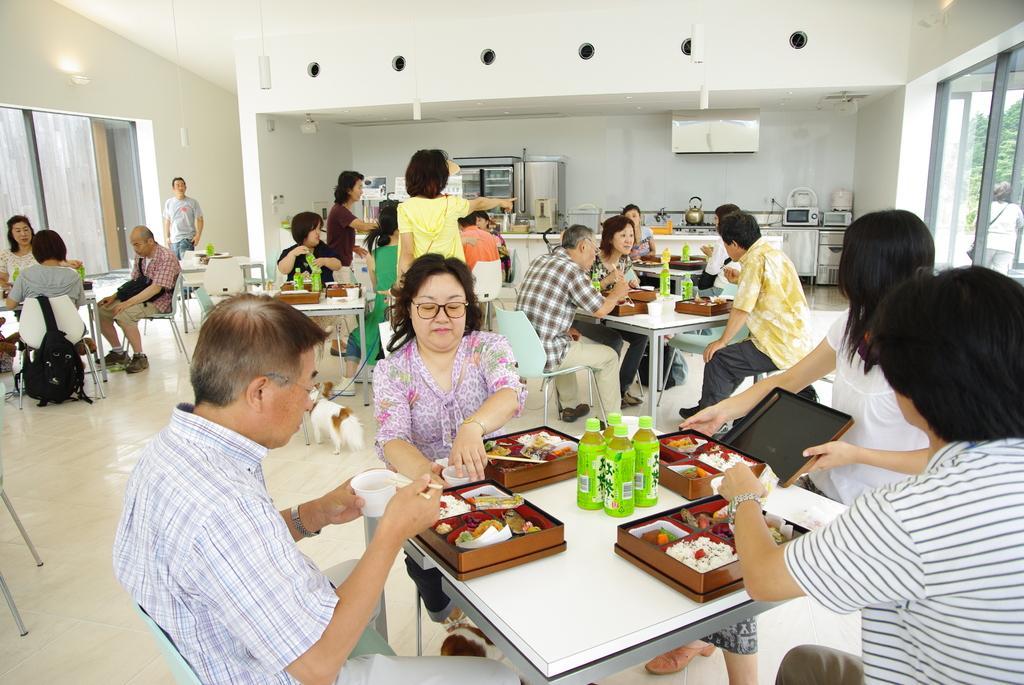Please provide a concise description of this image. In this image I can see the group of people with different color dresses. I can see few people are siting in-front of the table. On the table I can see the brown color boxes with food and bottles. I can also see few people are standing. In the background there are some kitchen utensils and to the side there are the glass windows. There is a light in the top. 